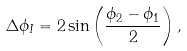Convert formula to latex. <formula><loc_0><loc_0><loc_500><loc_500>\Delta \phi _ { I } = 2 \sin \left ( \frac { \phi _ { 2 } - \phi _ { 1 } } { 2 } \right ) ,</formula> 